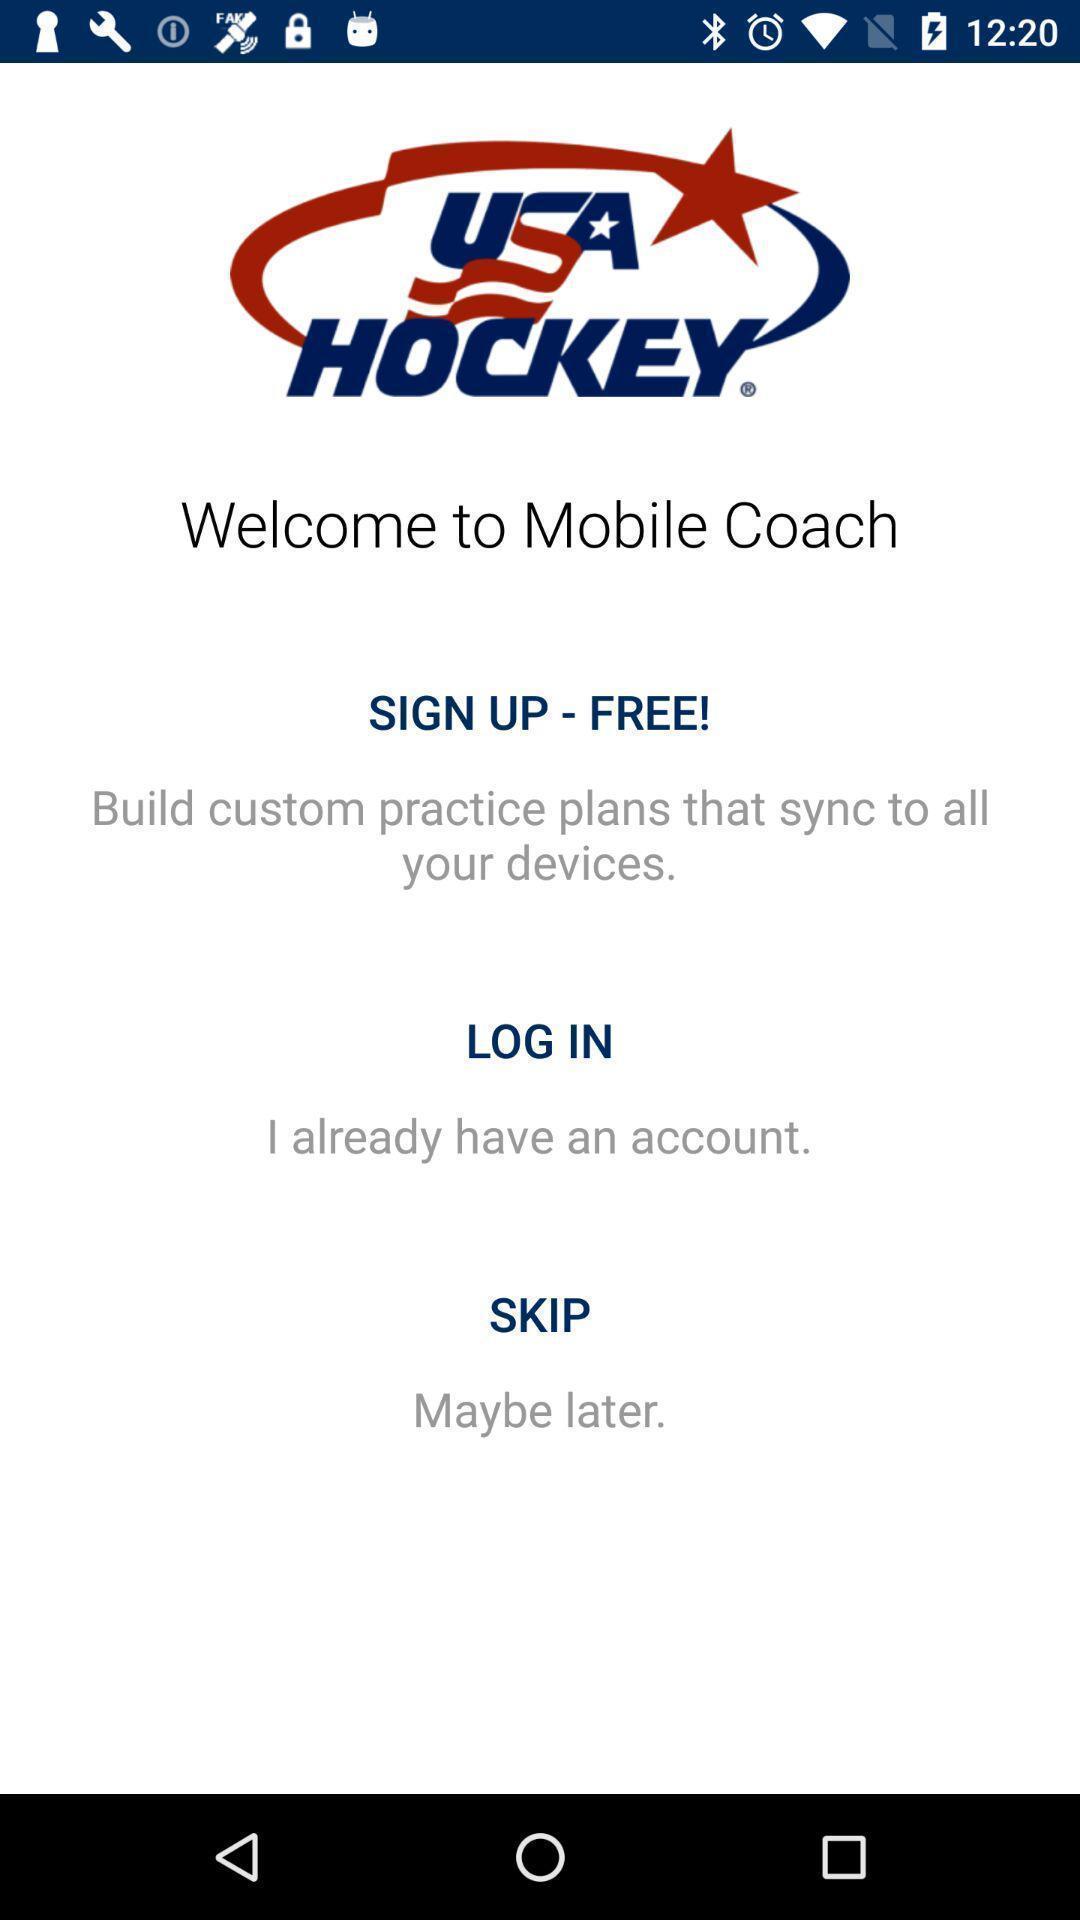Tell me about the visual elements in this screen capture. Welcome page displaying to sign in. 